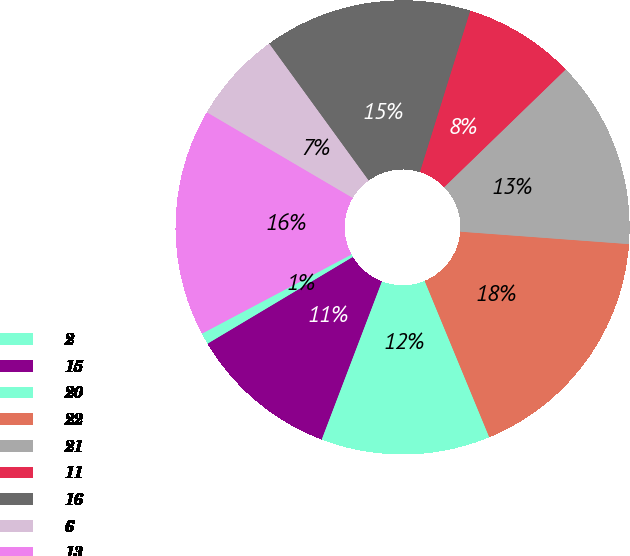Convert chart to OTSL. <chart><loc_0><loc_0><loc_500><loc_500><pie_chart><fcel>2<fcel>15<fcel>20<fcel>22<fcel>21<fcel>11<fcel>16<fcel>6<fcel>13<nl><fcel>0.82%<fcel>10.64%<fcel>12.03%<fcel>17.59%<fcel>13.42%<fcel>7.94%<fcel>14.81%<fcel>6.55%<fcel>16.2%<nl></chart> 